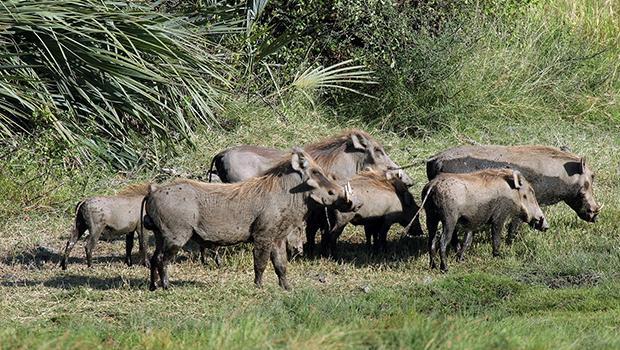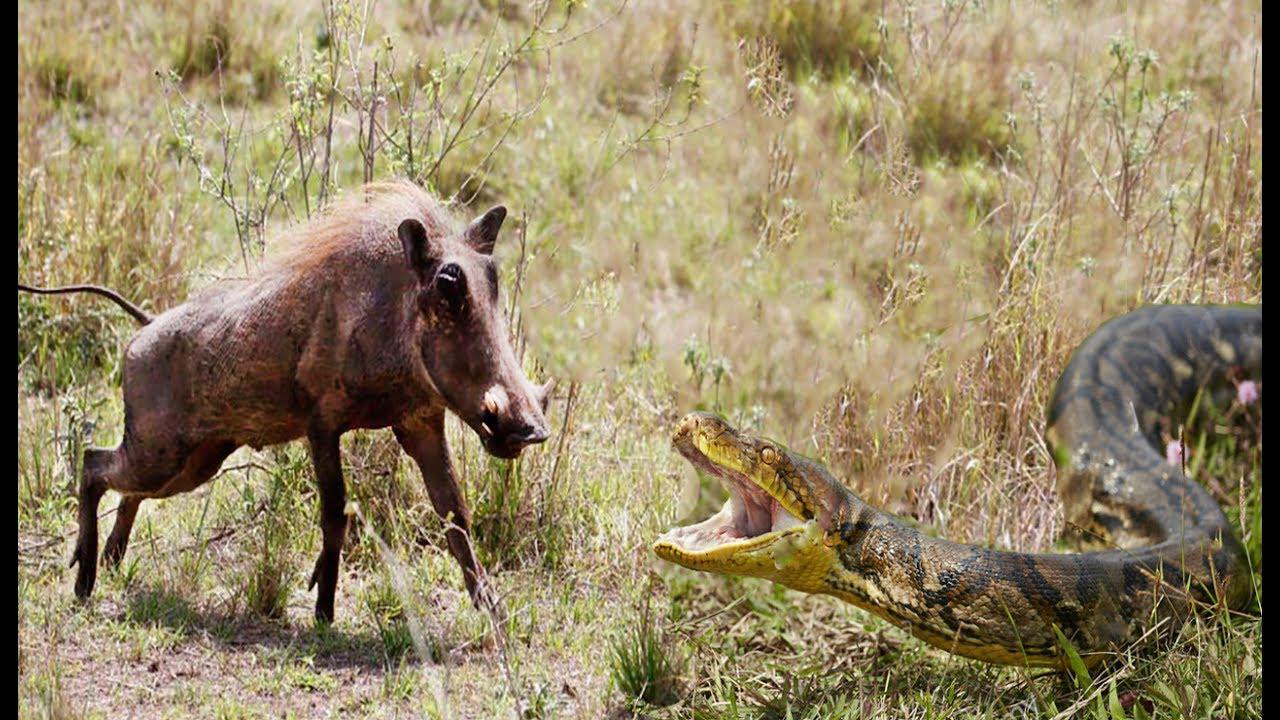The first image is the image on the left, the second image is the image on the right. Evaluate the accuracy of this statement regarding the images: "Right image contains one forward facing adult boar and multiple baby boars.". Is it true? Answer yes or no. No. The first image is the image on the left, the second image is the image on the right. Evaluate the accuracy of this statement regarding the images: "One of the images contains exactly two baby boars.". Is it true? Answer yes or no. No. 